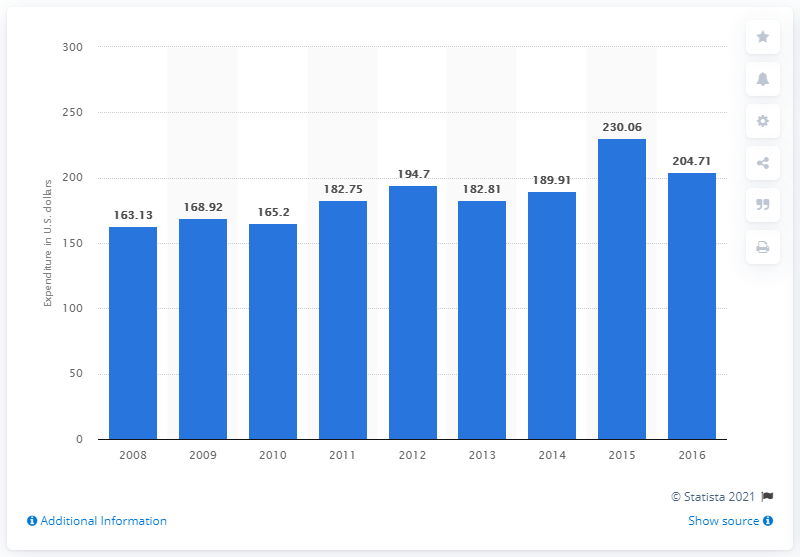List a handful of essential elements in this visual. In 2016, the average amount of money that consumers spent on pet food was 204.71 dollars. 